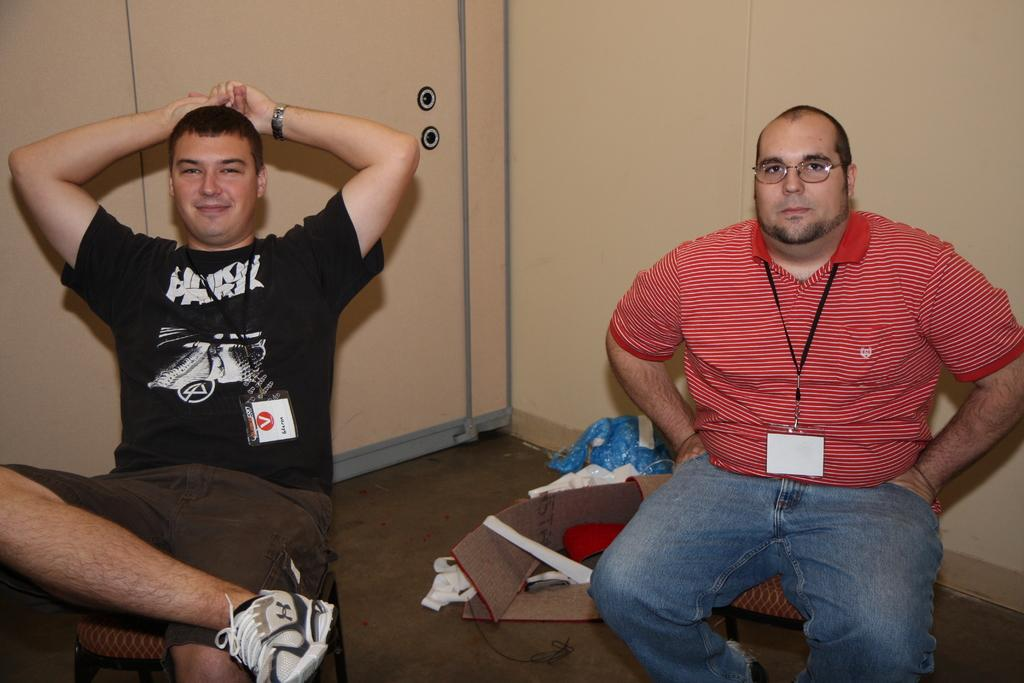How many men are present in the image? There are two men in the image. What are the men doing in the image? Both men are sitting in chairs. What are the men wearing in the image? Both men are wearing t-shirts. Can you describe any additional features of one of the men? One of the men is wearing spectacles. What can be seen in the background of the image? There is a cream-colored wall in the background of the image. What type of riddle is the man on the left side of the image telling? There is no indication in the image that the men are telling riddles or engaging in any conversation. Is there a fire visible in the image? No, there is no fire present in the image. 